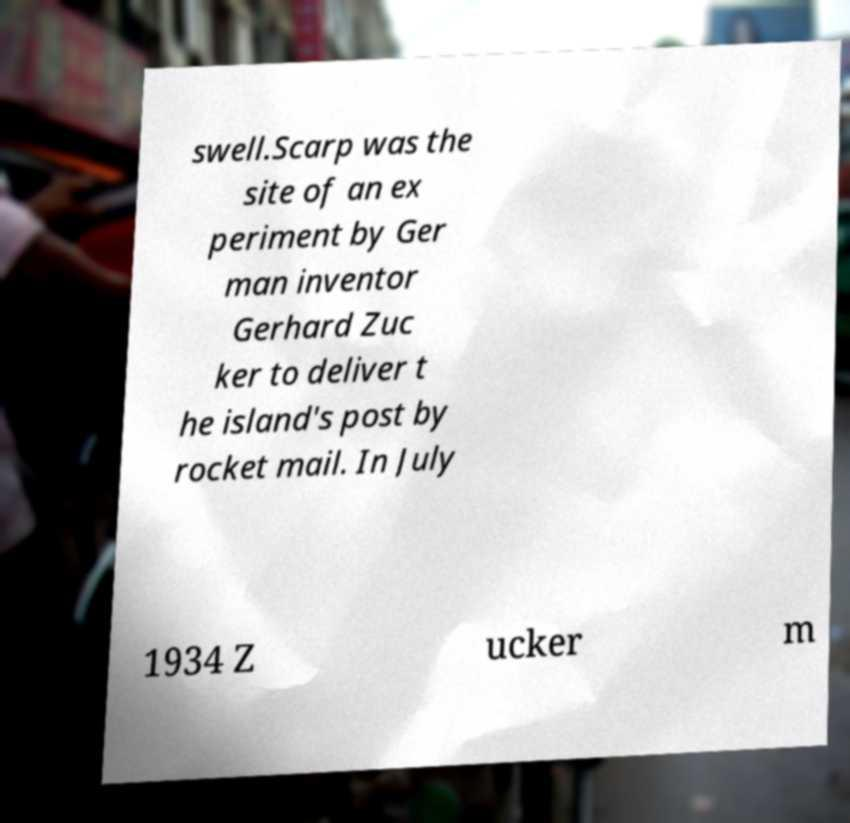There's text embedded in this image that I need extracted. Can you transcribe it verbatim? swell.Scarp was the site of an ex periment by Ger man inventor Gerhard Zuc ker to deliver t he island's post by rocket mail. In July 1934 Z ucker m 